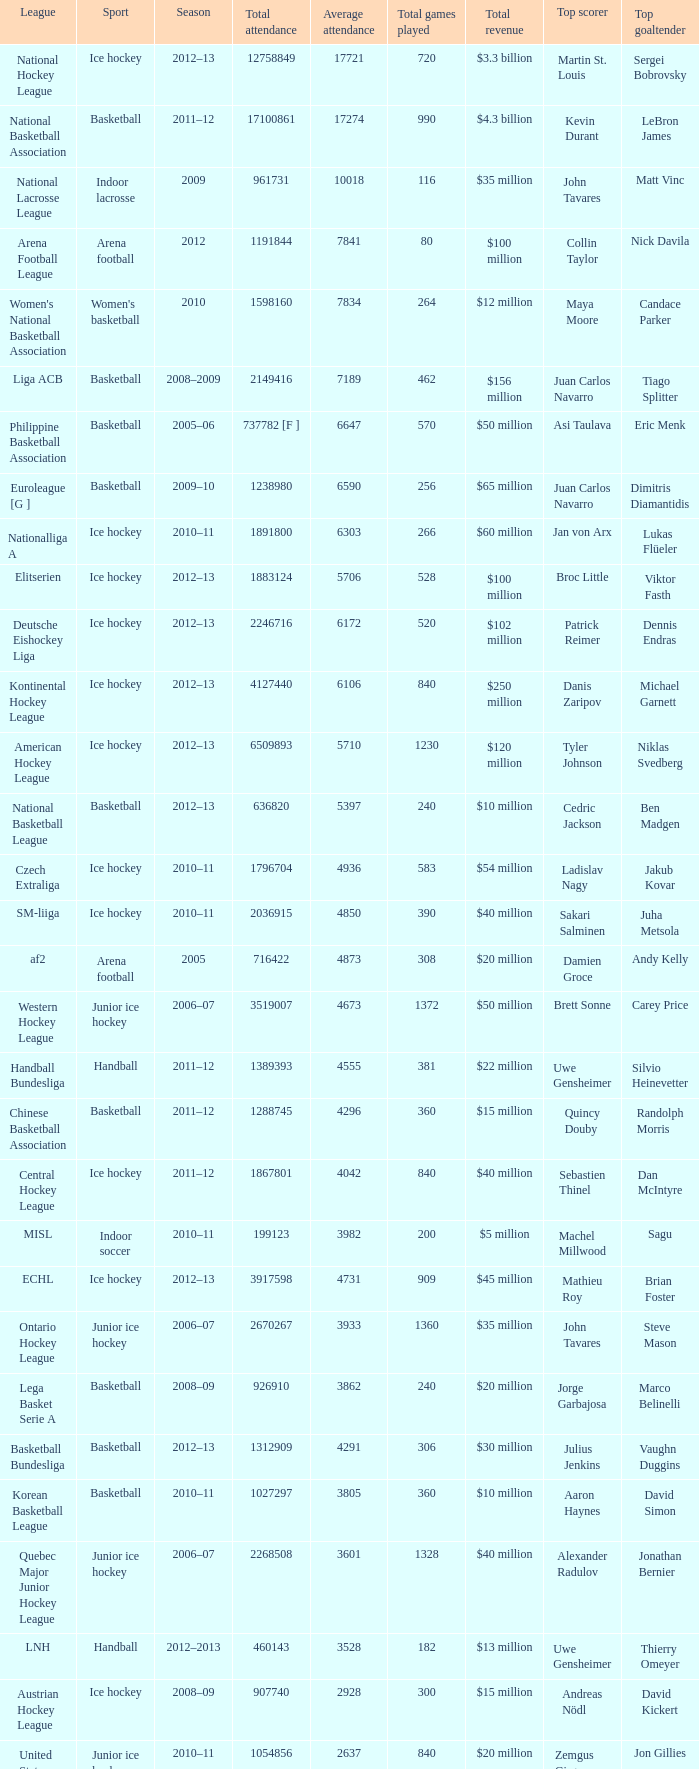What's the total attendance in rink hockey when the average attendance was smaller than 4850? 115000.0. 